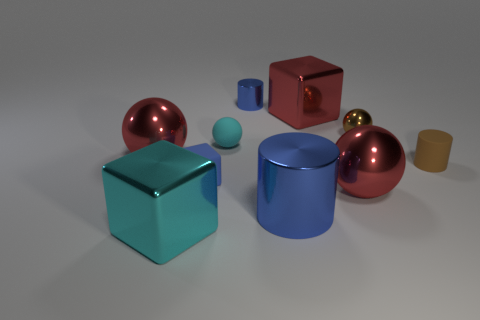What number of other things are the same shape as the tiny cyan rubber thing?
Offer a terse response. 3. Do the large blue metallic thing and the small shiny thing to the right of the large red block have the same shape?
Make the answer very short. No. The big object that is both on the left side of the cyan rubber object and in front of the tiny blue cube has what shape?
Provide a succinct answer. Cube. Is the number of brown balls left of the tiny rubber block the same as the number of small metal spheres behind the red metallic block?
Offer a very short reply. Yes. Is the shape of the tiny brown metallic thing that is behind the big blue metallic thing the same as  the small blue metal object?
Keep it short and to the point. No. What number of blue things are tiny blocks or metallic balls?
Your answer should be very brief. 1. There is another small object that is the same shape as the tiny brown metal object; what is its material?
Offer a very short reply. Rubber. What is the shape of the small blue thing that is behind the tiny metallic sphere?
Your response must be concise. Cylinder. Are there any tiny gray balls made of the same material as the big red cube?
Your answer should be very brief. No. Is the size of the rubber cube the same as the cyan matte ball?
Provide a short and direct response. Yes. 